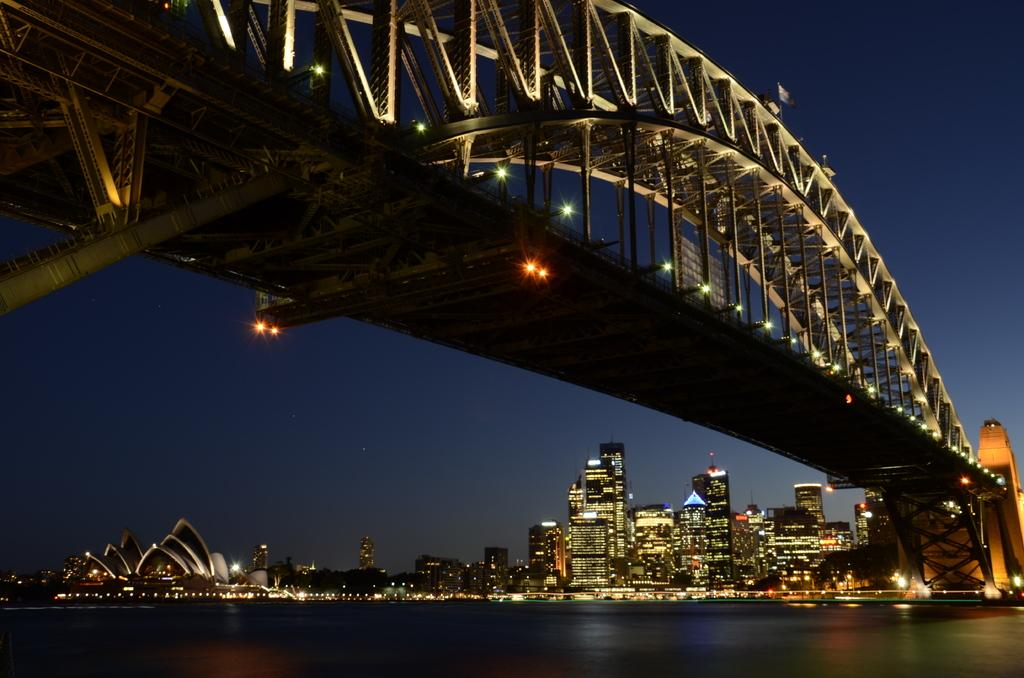What is present at the bottom of the image? There is water at the bottom of the image. What can be seen in the middle of the image? There are buildings with lights in the middle of the image. What structure is located at the top of the image? There is a bridge at the top of the image. What is visible in the background of the image? The sky is visible in the image. Can you see any signs of destruction caused by a beetle in the image? There is no beetle or any signs of destruction present in the image. Is there a basketball court visible in the image? There is no basketball court present in the image. 